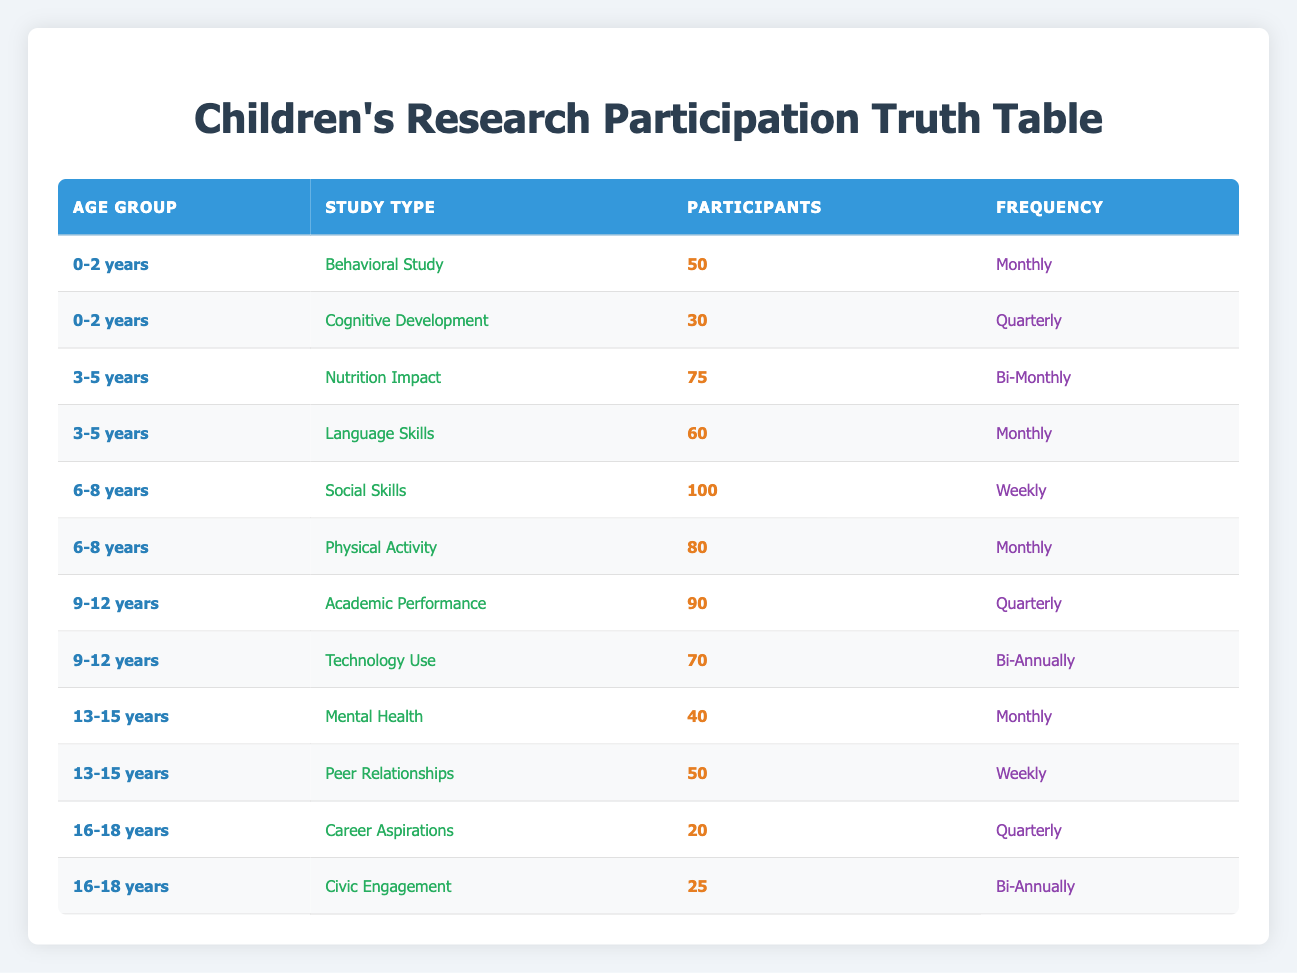What is the frequency of the "Social Skills" study for children aged 6-8 years? According to the table, the frequency for the "Social Skills" study, which has 100 participants, is "Weekly" for children in the 6-8 years age group.
Answer: Weekly How many total participants are involved in studies for the age group 3-5 years? From the table, the two studies for the 3-5 years age group are "Nutrition Impact" with 75 participants and "Language Skills" with 60 participants. Adding these gives a total of 75 + 60 = 135 participants.
Answer: 135 Is there a "Cognitive Development" study for the age group 0-2 years? Yes, the table lists a "Cognitive Development" study for the 0-2 years age group with 30 participants.
Answer: Yes What is the difference in the number of participants between "Mental Health" and "Peer Relationships" studies for the age group 13-15 years? The "Mental Health" study has 40 participants while the "Peer Relationships" study has 50 participants. The difference is 50 - 40 = 10 participants.
Answer: 10 What is the average number of participants in studies for the age group 9-12 years? For the 9-12 years age group, there are two studies: "Academic Performance" with 90 participants and "Technology Use" with 70 participants. The average is (90 + 70) / 2 = 160 / 2 = 80.
Answer: 80 How many studies have a "Monthly" frequency in the 6-8 years age group? Looking at the 6-8 years age group, there are two studies: "Social Skills" (Weekly) and "Physical Activity" (Monthly). Only "Physical Activity" has a monthly frequency, making the count one.
Answer: 1 Which age group has the highest total number of participants across all studies? The age group 6-8 years has "Social Skills" with 100 participants and "Physical Activity" with 80 participants. This gives a total of 100 + 80 = 180 participants, which is more than any other age group's totals.
Answer: 6-8 years Do any studies in the table have a frequency of "Bi-Annually"? Yes, the "Technology Use" study for the 9-12 years age group and the "Civic Engagement" study for the 16-18 years age group have a "Bi-Annually" frequency.
Answer: Yes What is the total number of participants involved in studies for the age group 16-18 years? The age group 16-18 years includes "Career Aspirations" with 20 participants and "Civic Engagement" with 25 participants. The total is 20 + 25 = 45 participants.
Answer: 45 